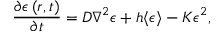Convert formula to latex. <formula><loc_0><loc_0><loc_500><loc_500>\frac { \partial \epsilon \left ( r , t \right ) } { \partial t } = D \nabla ^ { 2 } \epsilon + h \langle \epsilon \rangle - K \epsilon ^ { 2 } ,</formula> 